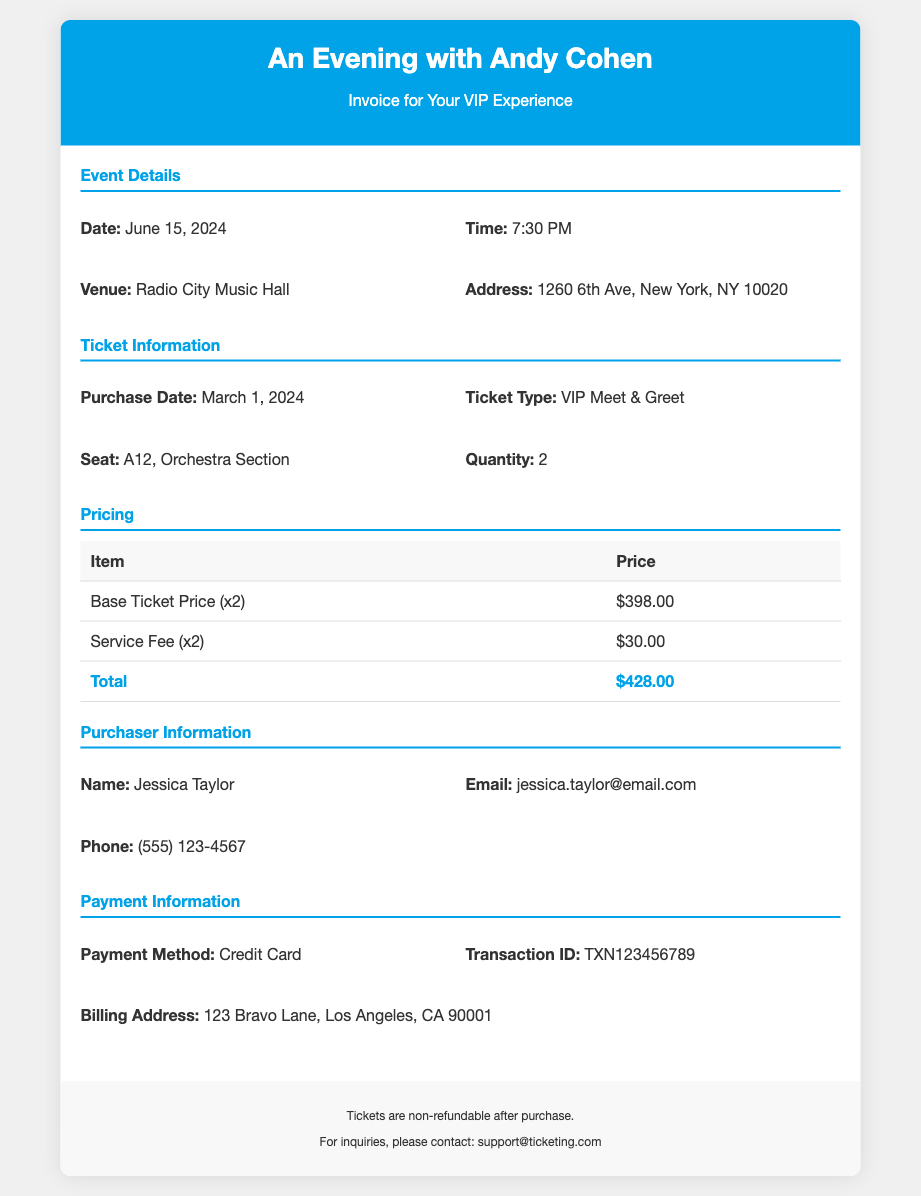What is the event date? The event date is stated in the event details section of the document.
Answer: June 15, 2024 What is the seat number? The seat number can be found under the ticket information section of the document.
Answer: A12 How many tickets were purchased? The number of tickets purchased is indicated in the ticket information section.
Answer: 2 What is the total price? The total price is the final amount listed in the pricing section of the document.
Answer: $428.00 Who is the purchaser? The name of the purchaser is provided in the purchaser information section.
Answer: Jessica Taylor What time does the event start? The start time of the event is mentioned in the event details section.
Answer: 7:30 PM What service fee is charged? The service fee can be found in the pricing section of the document, next to the item description.
Answer: $30.00 What payment method was used? The payment method is listed in the payment information section of the document.
Answer: Credit Card What is the venue of the event? The venue is stated in the event details section of the document.
Answer: Radio City Music Hall 